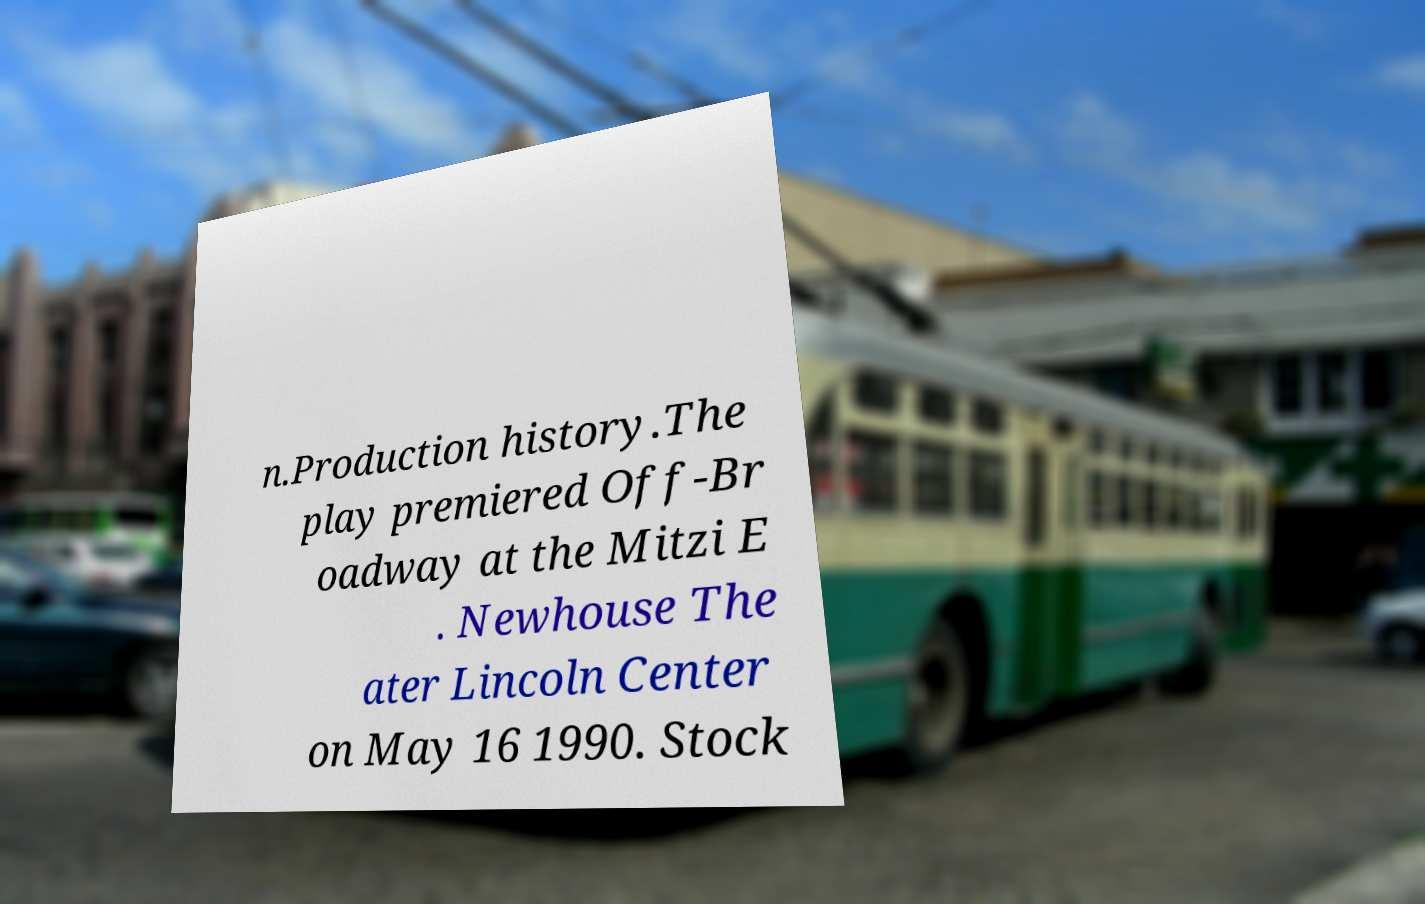For documentation purposes, I need the text within this image transcribed. Could you provide that? n.Production history.The play premiered Off-Br oadway at the Mitzi E . Newhouse The ater Lincoln Center on May 16 1990. Stock 